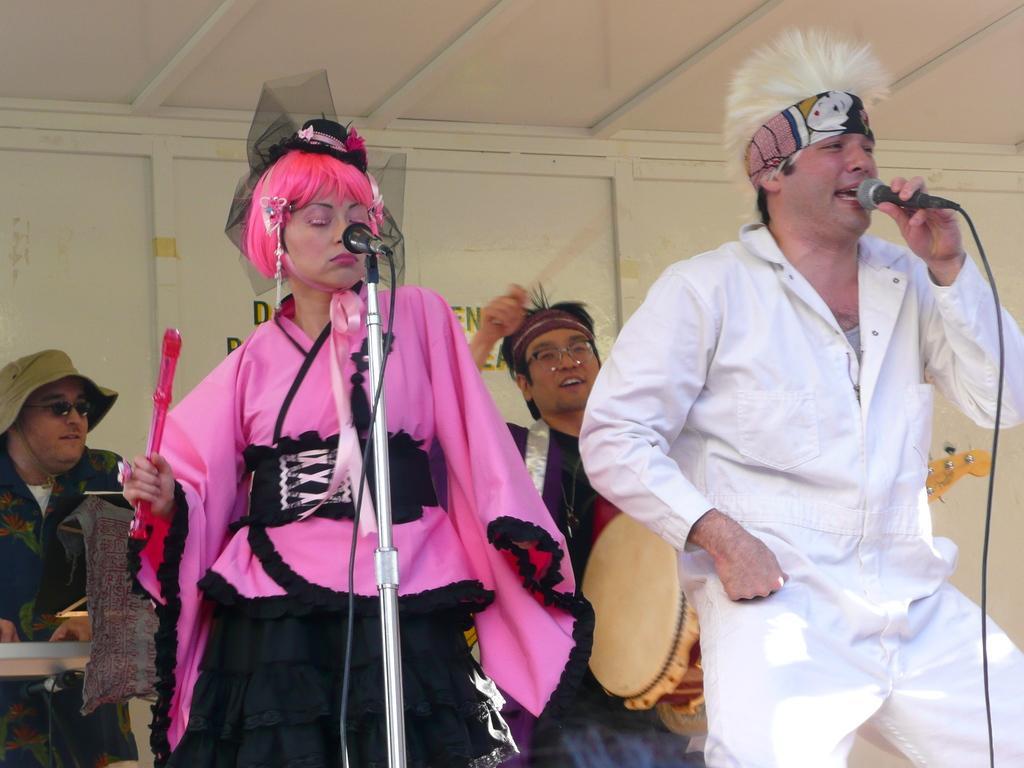Can you describe this image briefly? In this picture two people are standing front and their holding a microphone one person singing a song and back we can see two persons playing a musical instrument. 